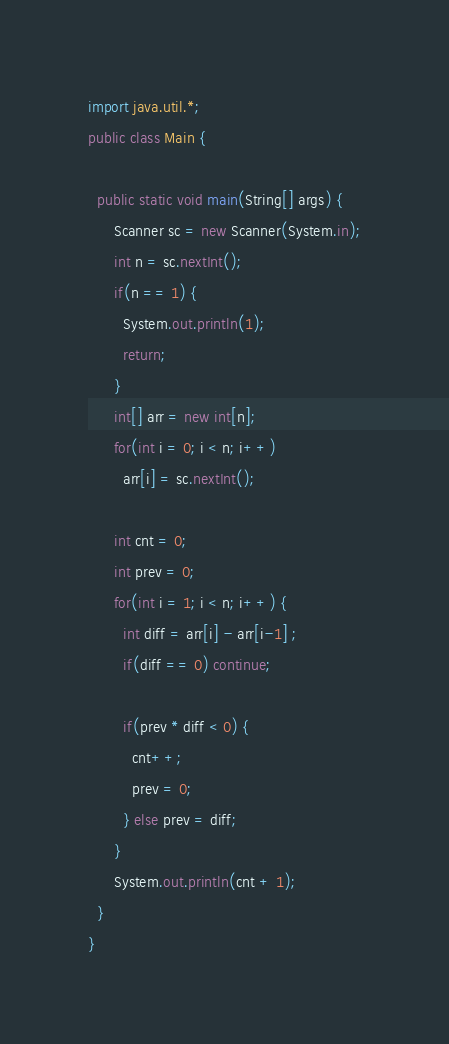<code> <loc_0><loc_0><loc_500><loc_500><_Java_>import java.util.*;
public class Main {

  public static void main(String[] args) { 
      Scanner sc = new Scanner(System.in);
      int n = sc.nextInt();
      if(n == 1) {
        System.out.println(1);
        return;
      }
      int[] arr = new int[n];
      for(int i = 0; i < n; i++)
        arr[i] = sc.nextInt();

      int cnt = 0;
      int prev = 0;
      for(int i = 1; i < n; i++) {
        int diff = arr[i] - arr[i-1] ;
        if(diff == 0) continue;
        
        if(prev * diff < 0) {
          cnt++;
          prev = 0;
        } else prev = diff;
      }
      System.out.println(cnt + 1);
  }
}</code> 